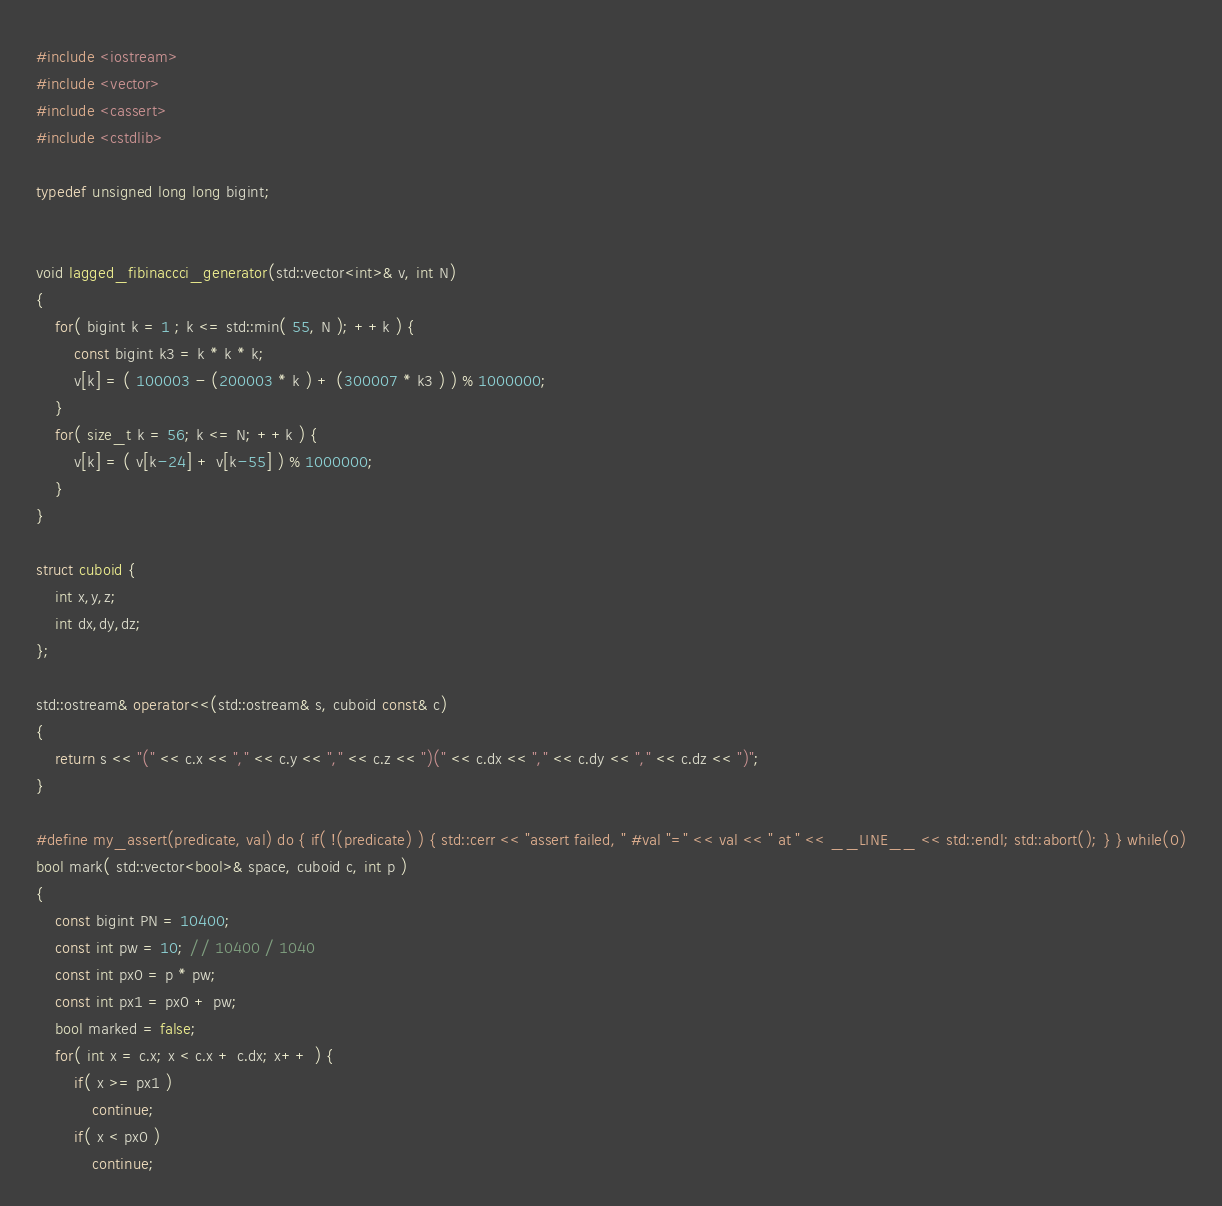<code> <loc_0><loc_0><loc_500><loc_500><_C++_>#include <iostream>
#include <vector>
#include <cassert>
#include <cstdlib>

typedef unsigned long long bigint;


void lagged_fibinaccci_generator(std::vector<int>& v, int N)
{
    for( bigint k = 1 ; k <= std::min( 55, N ); ++k ) {
        const bigint k3 = k * k * k;
        v[k] = ( 100003 - (200003 * k ) + (300007 * k3 ) ) % 1000000;
    }
    for( size_t k = 56; k <= N; ++k ) {
        v[k] = ( v[k-24] + v[k-55] ) % 1000000;
    }
}

struct cuboid {
    int x,y,z;
    int dx,dy,dz;
};

std::ostream& operator<<(std::ostream& s, cuboid const& c)
{
    return s << "(" << c.x << "," << c.y << "," << c.z << ")(" << c.dx << "," << c.dy << "," << c.dz << ")";
}

#define my_assert(predicate, val) do { if( !(predicate) ) { std::cerr << "assert failed, " #val "=" << val << " at " << __LINE__ << std::endl; std::abort(); } } while(0)
bool mark( std::vector<bool>& space, cuboid c, int p )
{
    const bigint PN = 10400;
    const int pw = 10; // 10400 / 1040
    const int px0 = p * pw;
    const int px1 = px0 + pw;
    bool marked = false;
    for( int x = c.x; x < c.x + c.dx; x++ ) {
        if( x >= px1 )
            continue;
        if( x < px0 )
            continue;</code> 